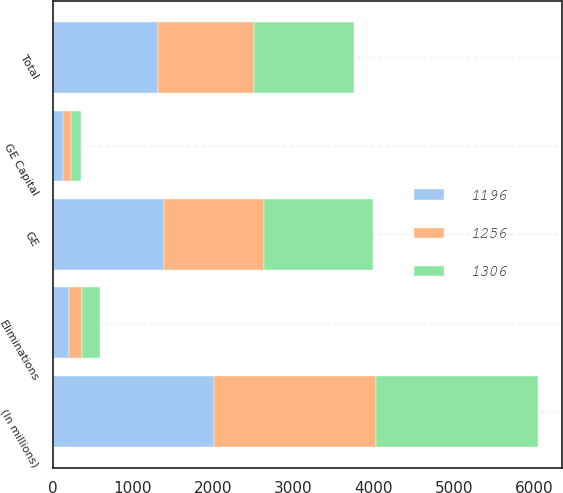<chart> <loc_0><loc_0><loc_500><loc_500><stacked_bar_chart><ecel><fcel>(In millions)<fcel>GE<fcel>GE Capital<fcel>Eliminations<fcel>Total<nl><fcel>1256<fcel>2015<fcel>1258<fcel>107<fcel>169<fcel>1196<nl><fcel>1306<fcel>2014<fcel>1356<fcel>123<fcel>223<fcel>1256<nl><fcel>1196<fcel>2013<fcel>1380<fcel>124<fcel>198<fcel>1306<nl></chart> 